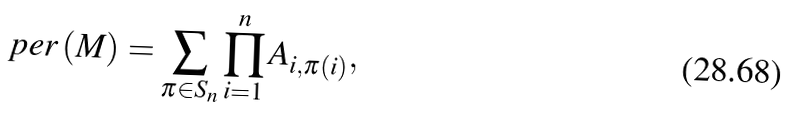Convert formula to latex. <formula><loc_0><loc_0><loc_500><loc_500>p e r \left ( M \right ) = \sum _ { \pi \in S _ { n } } \prod _ { i = 1 } ^ { n } A _ { i , \pi \left ( i \right ) } ,</formula> 